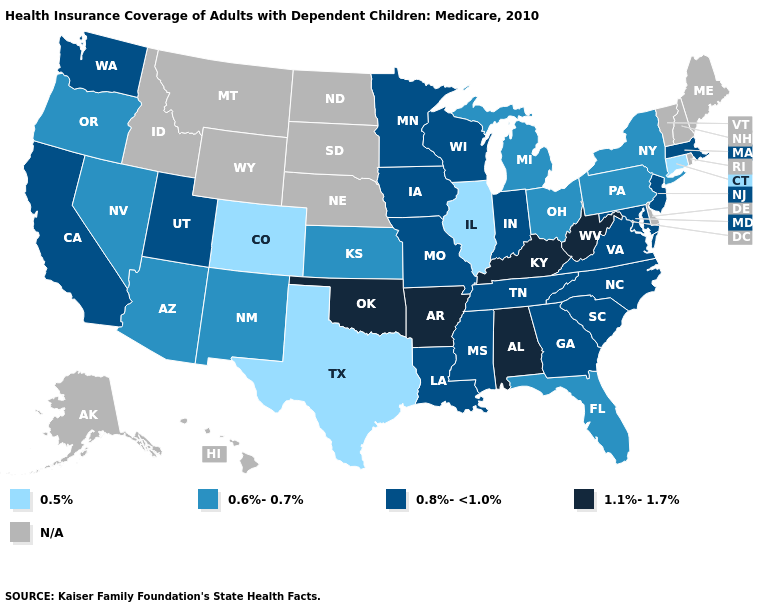Name the states that have a value in the range 0.8%-<1.0%?
Concise answer only. California, Georgia, Indiana, Iowa, Louisiana, Maryland, Massachusetts, Minnesota, Mississippi, Missouri, New Jersey, North Carolina, South Carolina, Tennessee, Utah, Virginia, Washington, Wisconsin. What is the value of Oregon?
Short answer required. 0.6%-0.7%. Among the states that border Connecticut , which have the lowest value?
Write a very short answer. New York. Name the states that have a value in the range 0.5%?
Short answer required. Colorado, Connecticut, Illinois, Texas. Which states have the highest value in the USA?
Quick response, please. Alabama, Arkansas, Kentucky, Oklahoma, West Virginia. Among the states that border North Carolina , which have the lowest value?
Quick response, please. Georgia, South Carolina, Tennessee, Virginia. Which states have the lowest value in the South?
Quick response, please. Texas. What is the value of Massachusetts?
Be succinct. 0.8%-<1.0%. What is the lowest value in the USA?
Answer briefly. 0.5%. How many symbols are there in the legend?
Quick response, please. 5. Among the states that border Michigan , which have the highest value?
Concise answer only. Indiana, Wisconsin. Name the states that have a value in the range 0.6%-0.7%?
Short answer required. Arizona, Florida, Kansas, Michigan, Nevada, New Mexico, New York, Ohio, Oregon, Pennsylvania. What is the value of New Jersey?
Answer briefly. 0.8%-<1.0%. Which states have the lowest value in the USA?
Quick response, please. Colorado, Connecticut, Illinois, Texas. Does the first symbol in the legend represent the smallest category?
Be succinct. Yes. 